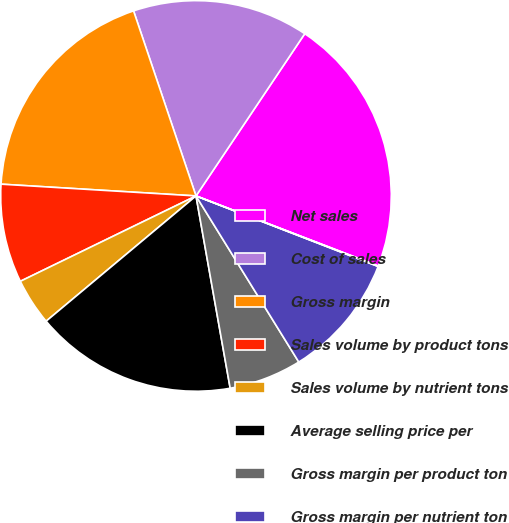Convert chart. <chart><loc_0><loc_0><loc_500><loc_500><pie_chart><fcel>Net sales<fcel>Cost of sales<fcel>Gross margin<fcel>Sales volume by product tons<fcel>Sales volume by nutrient tons<fcel>Average selling price per<fcel>Gross margin per product ton<fcel>Gross margin per nutrient ton<fcel>Depreciation and amortization<nl><fcel>21.44%<fcel>14.58%<fcel>18.86%<fcel>8.16%<fcel>3.88%<fcel>16.72%<fcel>6.02%<fcel>10.3%<fcel>0.04%<nl></chart> 